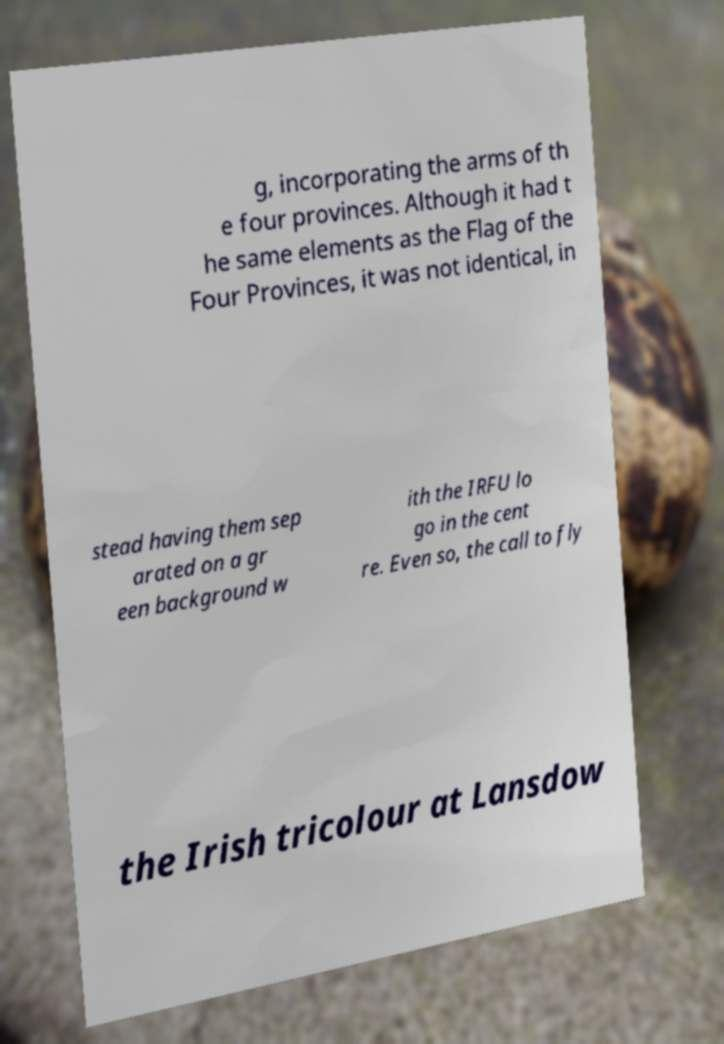I need the written content from this picture converted into text. Can you do that? g, incorporating the arms of th e four provinces. Although it had t he same elements as the Flag of the Four Provinces, it was not identical, in stead having them sep arated on a gr een background w ith the IRFU lo go in the cent re. Even so, the call to fly the Irish tricolour at Lansdow 